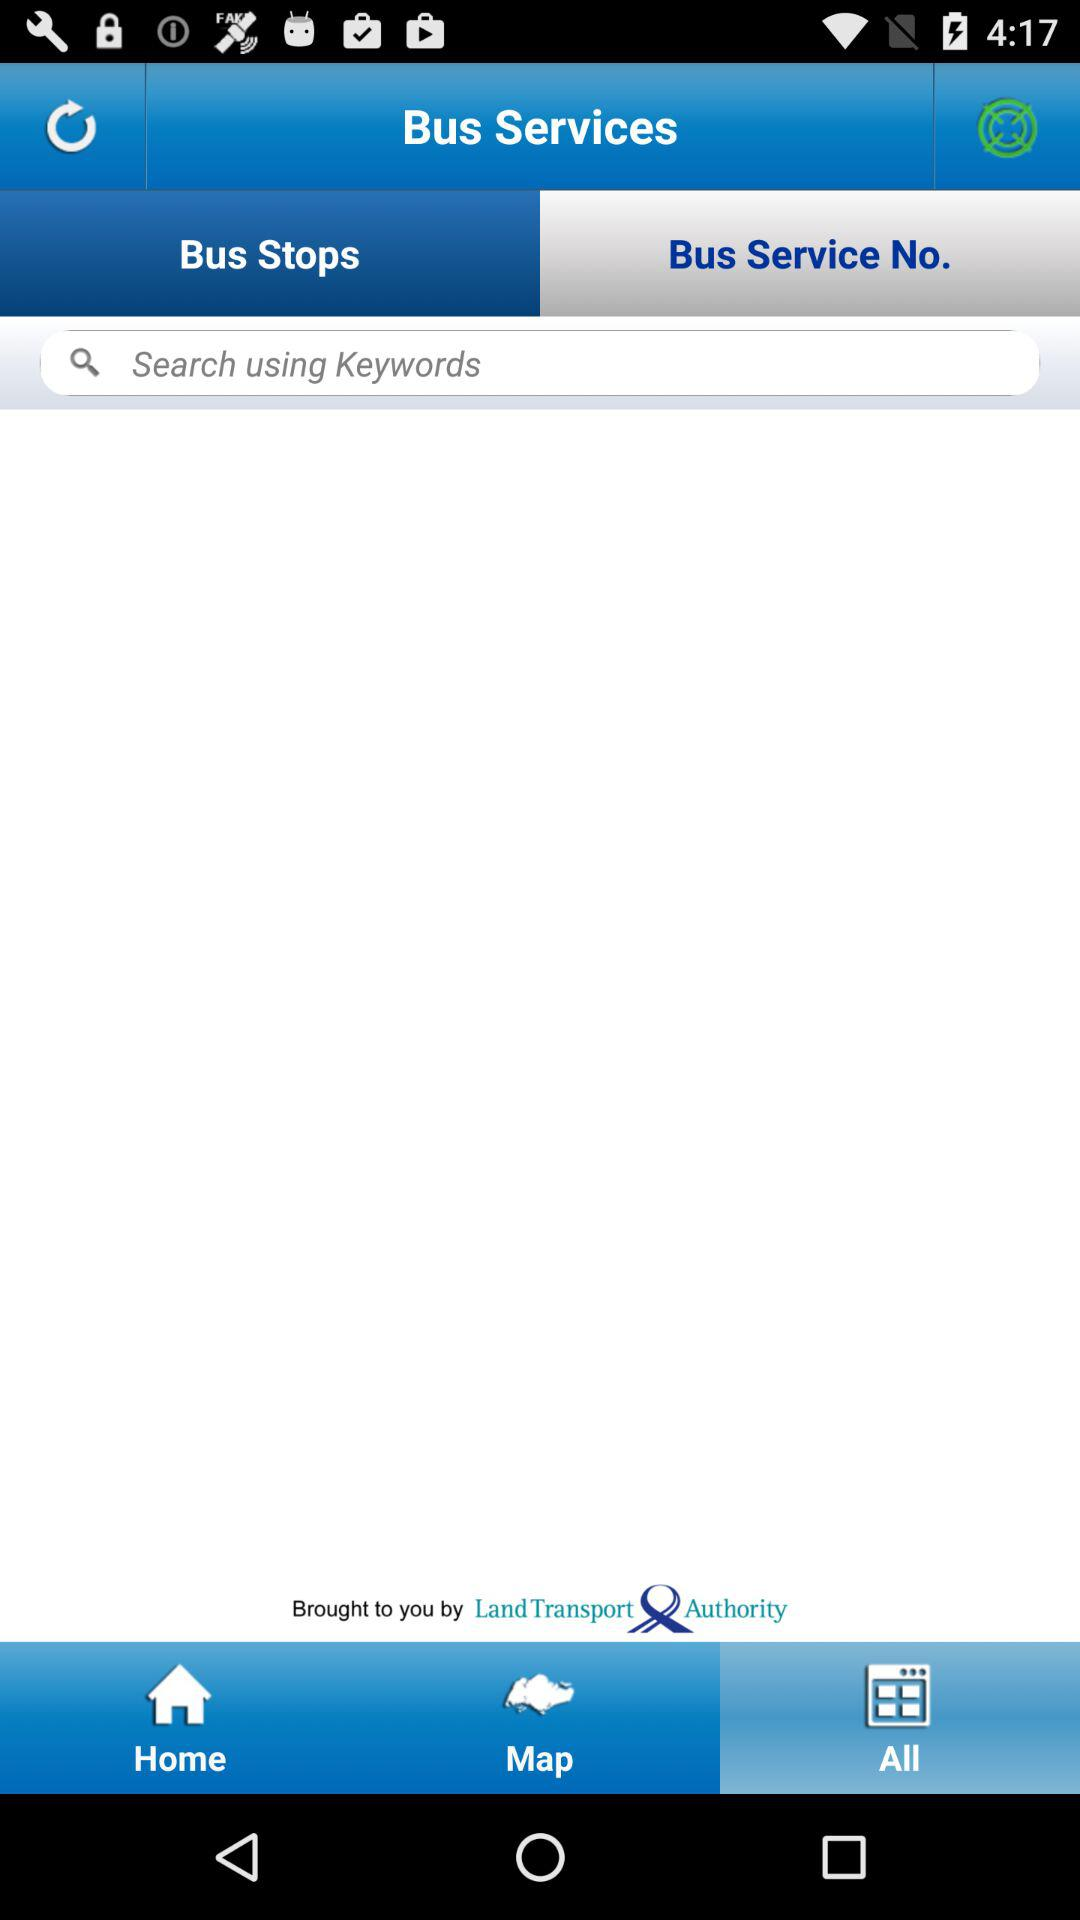Who developed the application?
When the provided information is insufficient, respond with <no answer>. <no answer> 